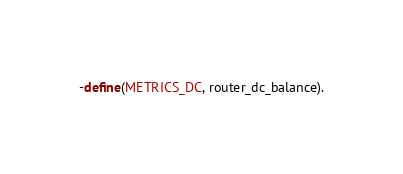Convert code to text. <code><loc_0><loc_0><loc_500><loc_500><_Erlang_>
-define(METRICS_DC, router_dc_balance).</code> 